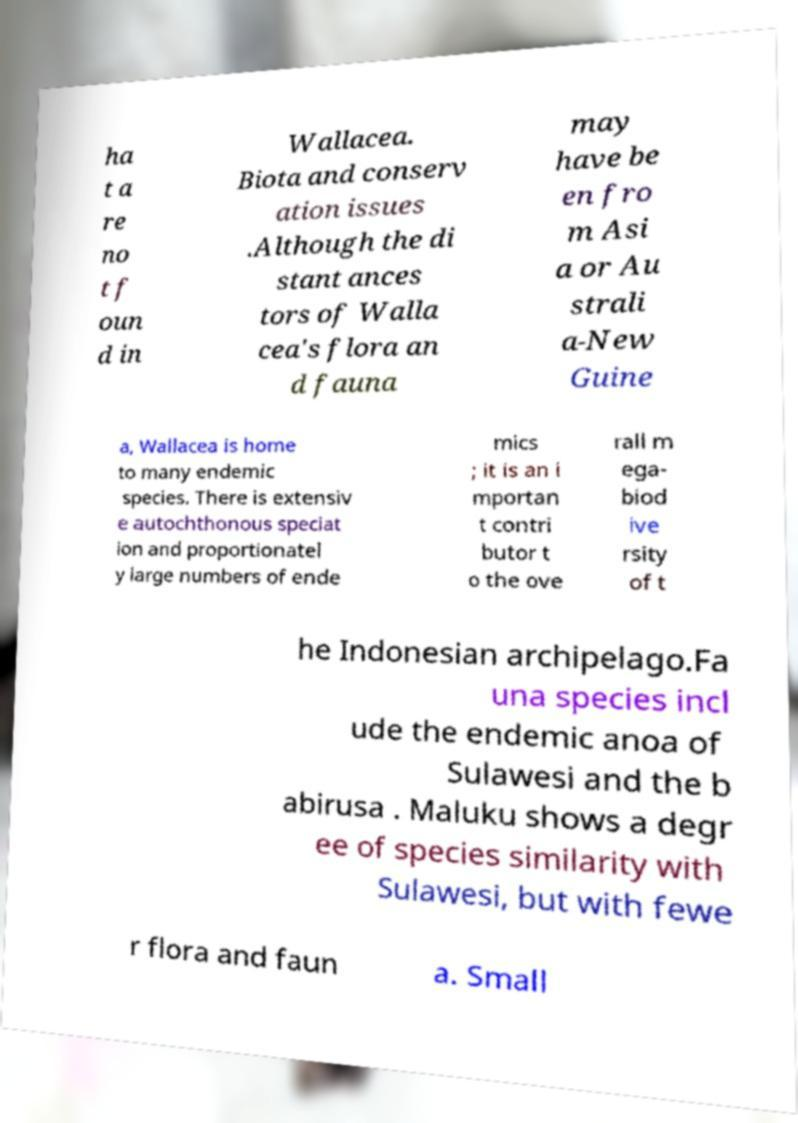Please read and relay the text visible in this image. What does it say? ha t a re no t f oun d in Wallacea. Biota and conserv ation issues .Although the di stant ances tors of Walla cea's flora an d fauna may have be en fro m Asi a or Au strali a-New Guine a, Wallacea is home to many endemic species. There is extensiv e autochthonous speciat ion and proportionatel y large numbers of ende mics ; it is an i mportan t contri butor t o the ove rall m ega- biod ive rsity of t he Indonesian archipelago.Fa una species incl ude the endemic anoa of Sulawesi and the b abirusa . Maluku shows a degr ee of species similarity with Sulawesi, but with fewe r flora and faun a. Small 